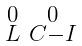<formula> <loc_0><loc_0><loc_500><loc_500>\begin{smallmatrix} 0 & 0 \\ L & C - I \end{smallmatrix}</formula> 